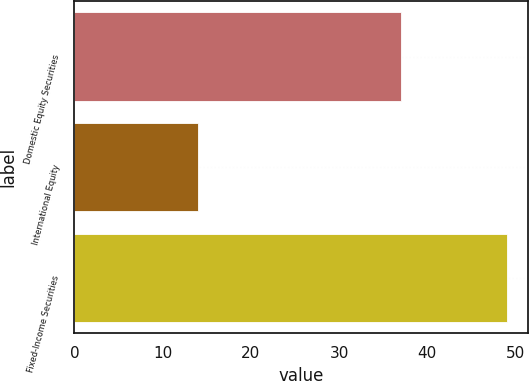<chart> <loc_0><loc_0><loc_500><loc_500><bar_chart><fcel>Domestic Equity Securities<fcel>International Equity<fcel>Fixed-Income Securities<nl><fcel>37<fcel>14<fcel>49<nl></chart> 